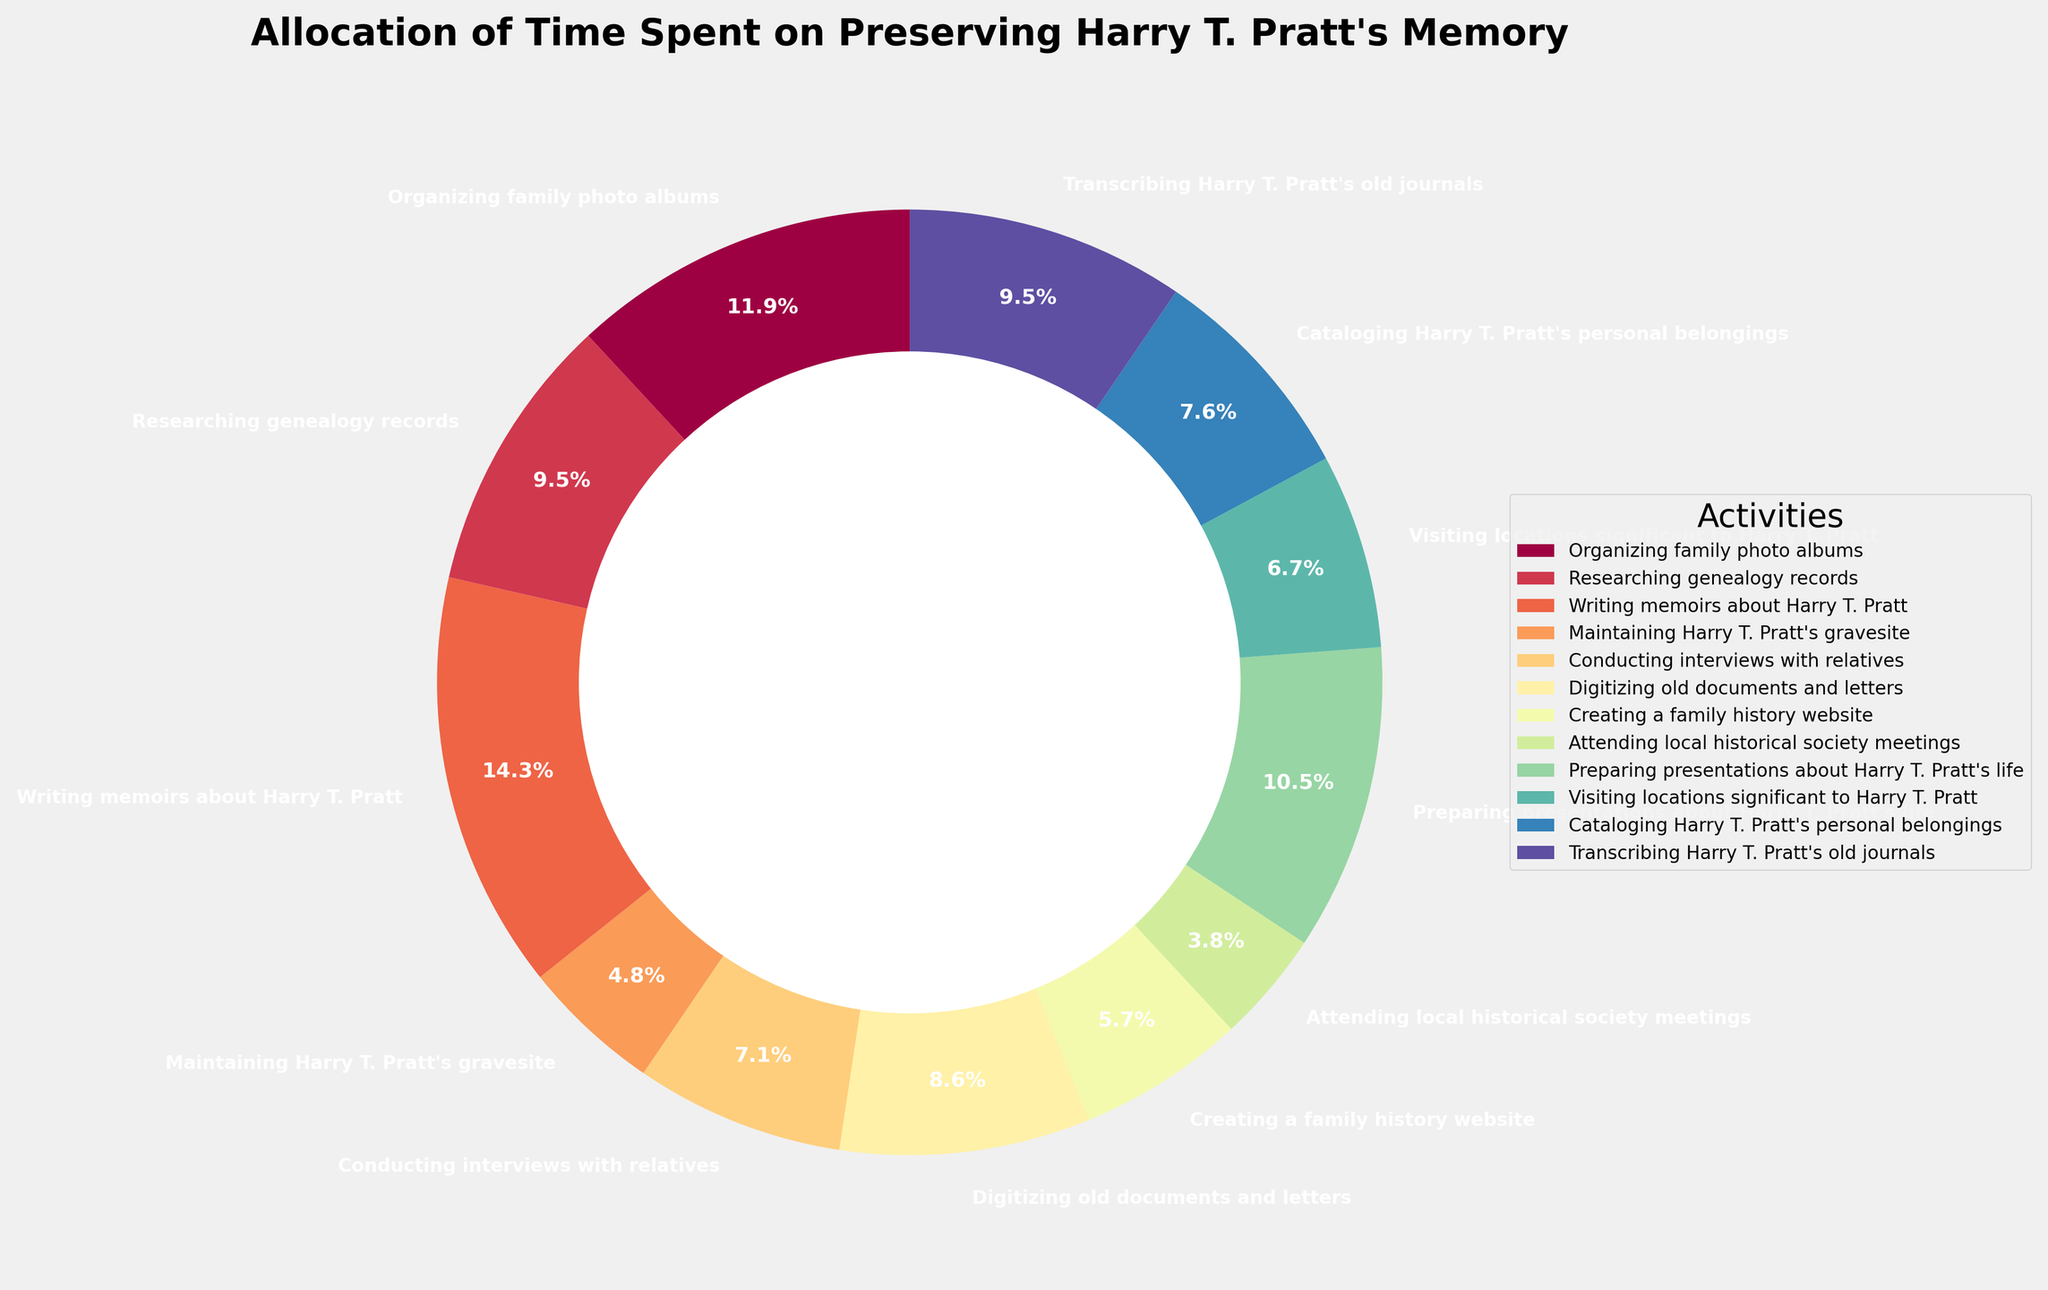What's the activity with the highest allocation of time? By looking at the pie chart, find the activity with the largest slice. In this case, "Writing memoirs about Harry T. Pratt" occupies the largest portion of the pie chart at 1.1% of the total time allocation.
Answer: Writing memoirs about Harry T. Pratt Which activities take up less time than creating a family history website? Compare the size of the pie slices for each activity with that for "Creating a family history website." The smaller slices include "Maintaining Harry T. Pratt's gravesite" (10 hours), "Attending local historical society meetings" (8 hours), and "Visiting locations significant to Harry T. Pratt" (14 hours).
Answer: Maintaining Harry T. Pratt's gravesite, Attending local historical society meetings, Visiting locations significant to Harry T. Pratt How much more time is spent on conducting interviews with relatives than digitizing old documents and letters? From the chart, compare the pie slices for the two activities. "Conducting interviews with relatives" uses 15 hours while "Digitizing old documents and letters" uses 18 hours. Perform the subtraction: 18 - 15 = 3 hours.
Answer: 3 hours Which activities are done equally often? Scan the pie chart to identify activities with equal-sized slices. "Researching genealogy records" and "Transcribing Harry T. Pratt's old journals" each have 20 hours allocated to them.
Answer: Researching genealogy records, Transcribing Harry T. Pratt's old journals What's the total time spent on activities related to preserving Harry T. Pratt's memory that involve writing or transcribing? Calculate the sum of hours for activities involving writing or transcribing: "Writing memoirs about Harry T. Pratt" (30 hours) + "Transcribing Harry T. Pratt's old journals" (20 hours) = 50 hours.
Answer: 50 hours 